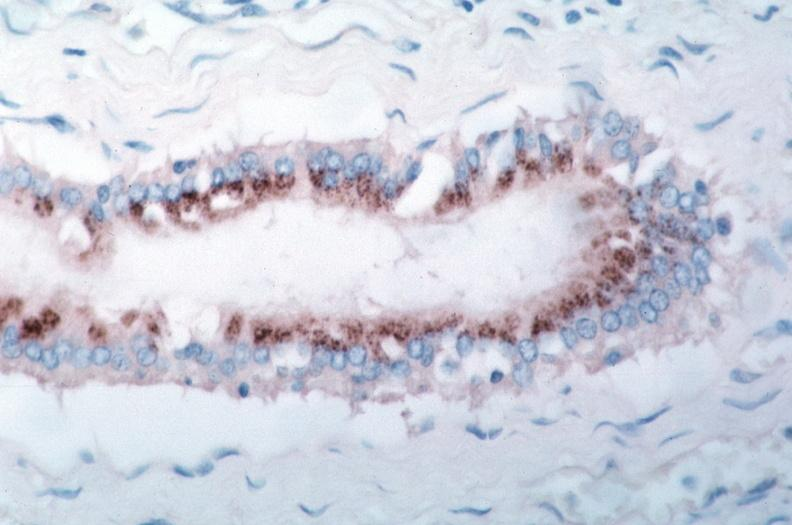what does this image show?
Answer the question using a single word or phrase. Vasculitis 